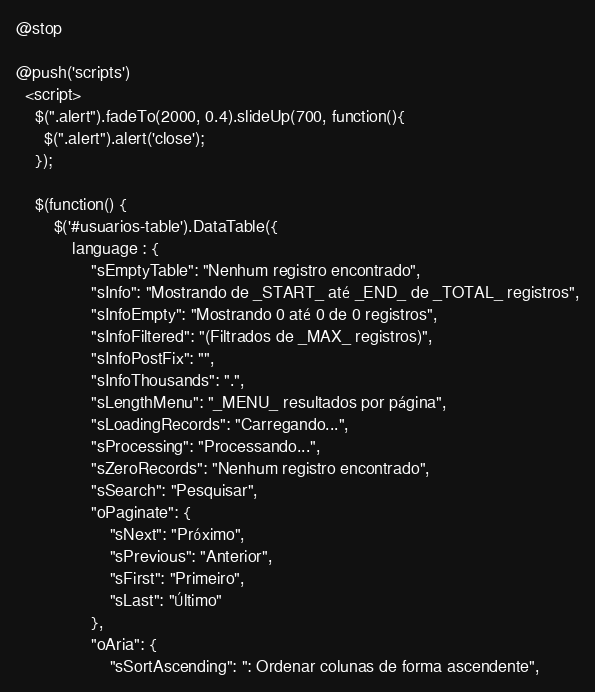<code> <loc_0><loc_0><loc_500><loc_500><_PHP_>@stop

@push('scripts')
  <script>
    $(".alert").fadeTo(2000, 0.4).slideUp(700, function(){
      $(".alert").alert('close');
    });

    $(function() {
        $('#usuarios-table').DataTable({
            language : {
                "sEmptyTable": "Nenhum registro encontrado",
                "sInfo": "Mostrando de _START_ até _END_ de _TOTAL_ registros",
                "sInfoEmpty": "Mostrando 0 até 0 de 0 registros",
                "sInfoFiltered": "(Filtrados de _MAX_ registros)",
                "sInfoPostFix": "",
                "sInfoThousands": ".",
                "sLengthMenu": "_MENU_ resultados por página",
                "sLoadingRecords": "Carregando...",
                "sProcessing": "Processando...",
                "sZeroRecords": "Nenhum registro encontrado",
                "sSearch": "Pesquisar",
                "oPaginate": {
                    "sNext": "Próximo",
                    "sPrevious": "Anterior",
                    "sFirst": "Primeiro",
                    "sLast": "Último"
                },
                "oAria": {
                    "sSortAscending": ": Ordenar colunas de forma ascendente",</code> 